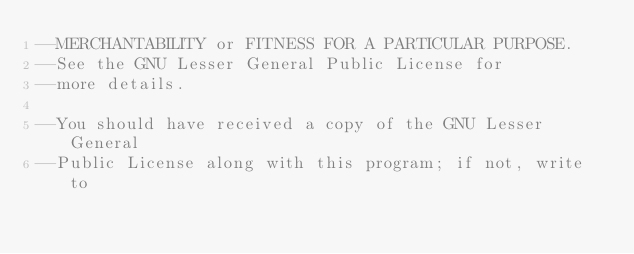Convert code to text. <code><loc_0><loc_0><loc_500><loc_500><_Lua_>--MERCHANTABILITY or FITNESS FOR A PARTICULAR PURPOSE. 
--See the GNU Lesser General Public License for
--more details.

--You should have received a copy of the GNU Lesser General 
--Public License along with this program; if not, write to</code> 